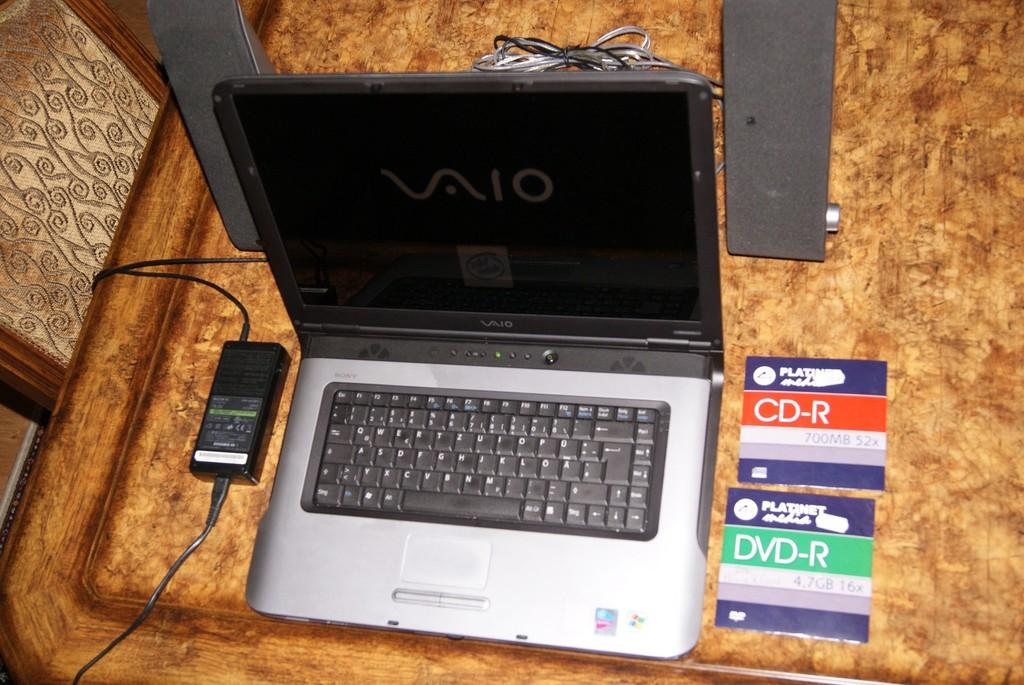Provide a one-sentence caption for the provided image. A laptop opened up next to CD-R and DVD-R cases. 